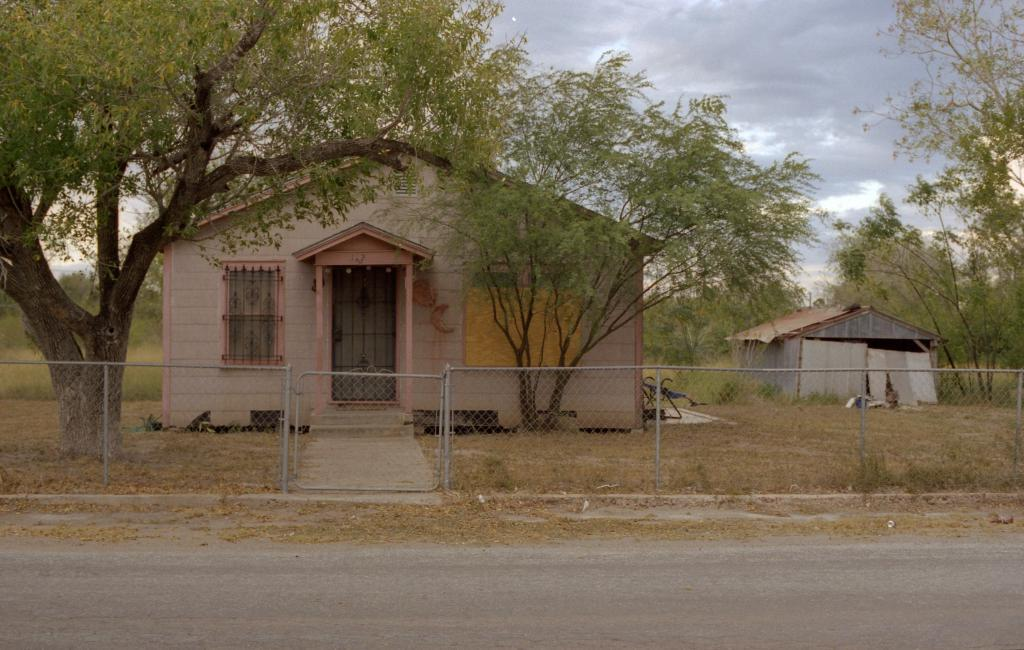What is located in the foreground of the image? There is a road in the foreground of the image. What structures can be seen in the background of the image? There is a house and a shed in the background of the image. What type of vegetation is visible in the background of the image? There are trees and grass in the background of the image. What is visible in the sky in the background of the image? The sky is visible in the background of the image, and there is a cloud in the sky. What color is the tail of the volleyball in the image? There is no volleyball present in the image, so there is no tail to describe. 